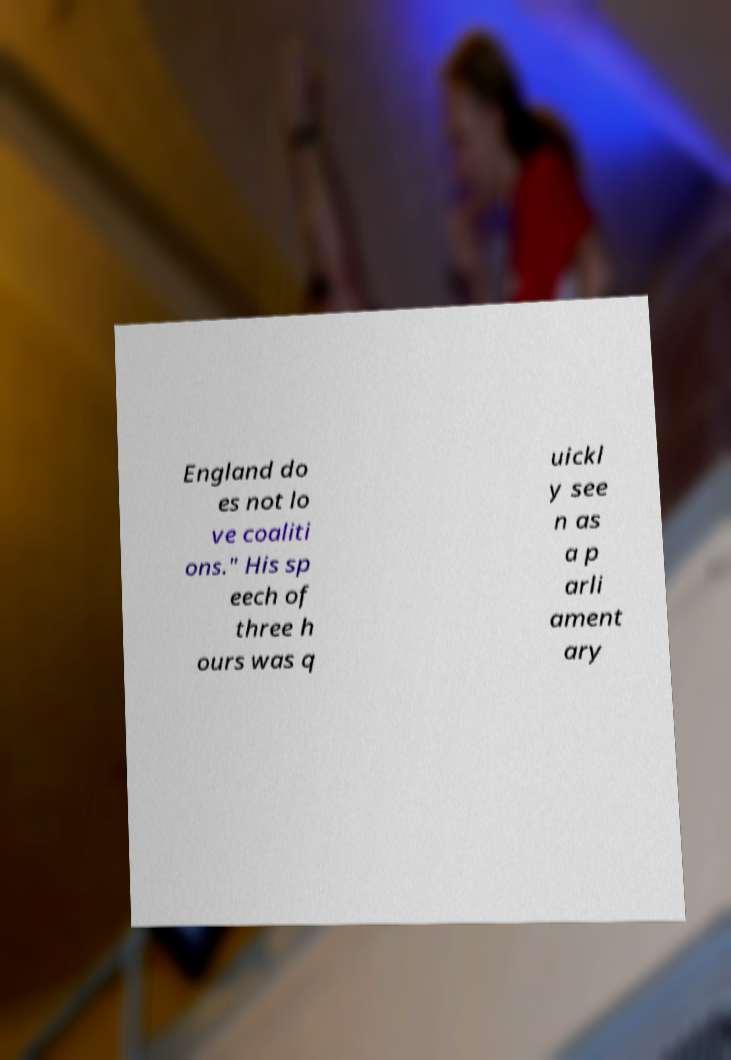Can you read and provide the text displayed in the image?This photo seems to have some interesting text. Can you extract and type it out for me? England do es not lo ve coaliti ons." His sp eech of three h ours was q uickl y see n as a p arli ament ary 